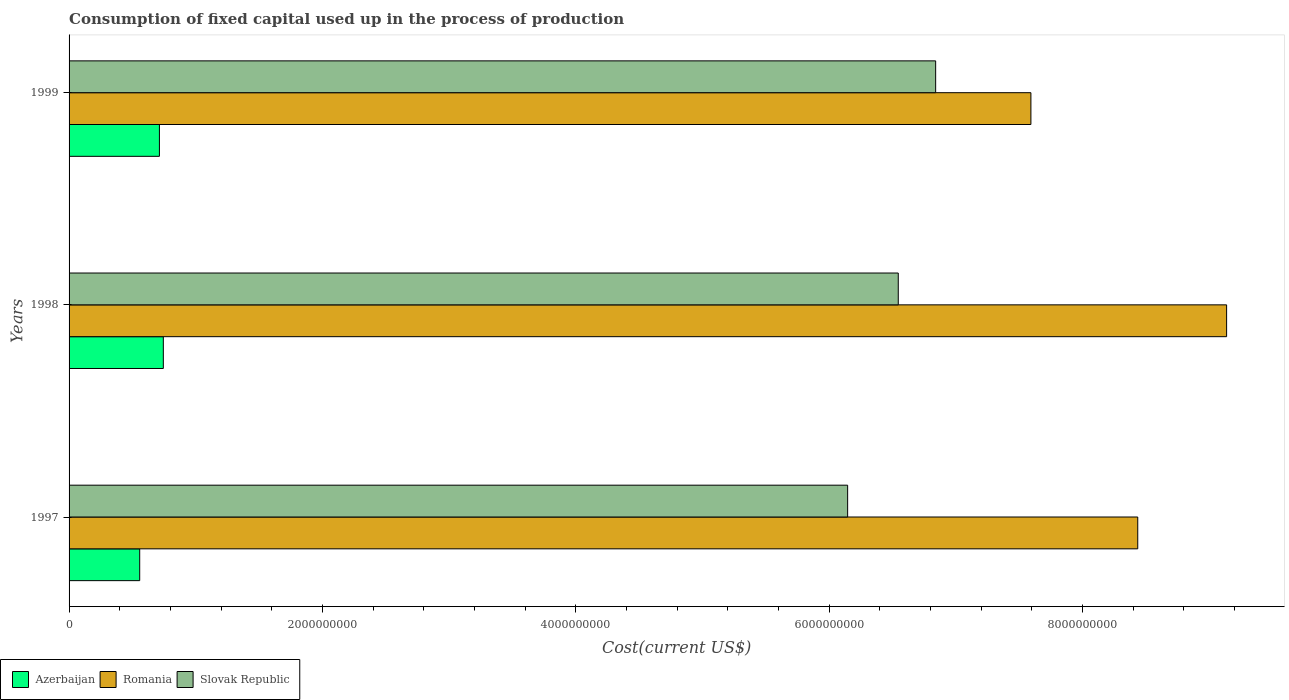Are the number of bars on each tick of the Y-axis equal?
Make the answer very short. Yes. How many bars are there on the 1st tick from the bottom?
Ensure brevity in your answer.  3. What is the amount consumed in the process of production in Slovak Republic in 1998?
Keep it short and to the point. 6.55e+09. Across all years, what is the maximum amount consumed in the process of production in Azerbaijan?
Your answer should be compact. 7.44e+08. Across all years, what is the minimum amount consumed in the process of production in Azerbaijan?
Give a very brief answer. 5.58e+08. In which year was the amount consumed in the process of production in Azerbaijan minimum?
Provide a succinct answer. 1997. What is the total amount consumed in the process of production in Romania in the graph?
Make the answer very short. 2.52e+1. What is the difference between the amount consumed in the process of production in Azerbaijan in 1998 and that in 1999?
Keep it short and to the point. 3.07e+07. What is the difference between the amount consumed in the process of production in Azerbaijan in 1998 and the amount consumed in the process of production in Romania in 1999?
Provide a short and direct response. -6.85e+09. What is the average amount consumed in the process of production in Azerbaijan per year?
Your response must be concise. 6.72e+08. In the year 1998, what is the difference between the amount consumed in the process of production in Azerbaijan and amount consumed in the process of production in Slovak Republic?
Your response must be concise. -5.80e+09. In how many years, is the amount consumed in the process of production in Slovak Republic greater than 8000000000 US$?
Your response must be concise. 0. What is the ratio of the amount consumed in the process of production in Slovak Republic in 1998 to that in 1999?
Make the answer very short. 0.96. Is the difference between the amount consumed in the process of production in Azerbaijan in 1997 and 1999 greater than the difference between the amount consumed in the process of production in Slovak Republic in 1997 and 1999?
Give a very brief answer. Yes. What is the difference between the highest and the second highest amount consumed in the process of production in Azerbaijan?
Ensure brevity in your answer.  3.07e+07. What is the difference between the highest and the lowest amount consumed in the process of production in Romania?
Ensure brevity in your answer.  1.55e+09. In how many years, is the amount consumed in the process of production in Romania greater than the average amount consumed in the process of production in Romania taken over all years?
Your response must be concise. 2. Is the sum of the amount consumed in the process of production in Romania in 1997 and 1998 greater than the maximum amount consumed in the process of production in Slovak Republic across all years?
Your response must be concise. Yes. What does the 3rd bar from the top in 1999 represents?
Give a very brief answer. Azerbaijan. What does the 3rd bar from the bottom in 1999 represents?
Make the answer very short. Slovak Republic. Is it the case that in every year, the sum of the amount consumed in the process of production in Romania and amount consumed in the process of production in Azerbaijan is greater than the amount consumed in the process of production in Slovak Republic?
Provide a short and direct response. Yes. How many bars are there?
Make the answer very short. 9. Are all the bars in the graph horizontal?
Provide a succinct answer. Yes. How many years are there in the graph?
Your answer should be compact. 3. What is the difference between two consecutive major ticks on the X-axis?
Your response must be concise. 2.00e+09. Does the graph contain grids?
Ensure brevity in your answer.  No. How are the legend labels stacked?
Offer a terse response. Horizontal. What is the title of the graph?
Provide a succinct answer. Consumption of fixed capital used up in the process of production. What is the label or title of the X-axis?
Offer a terse response. Cost(current US$). What is the label or title of the Y-axis?
Keep it short and to the point. Years. What is the Cost(current US$) in Azerbaijan in 1997?
Provide a succinct answer. 5.58e+08. What is the Cost(current US$) in Romania in 1997?
Offer a terse response. 8.44e+09. What is the Cost(current US$) of Slovak Republic in 1997?
Make the answer very short. 6.15e+09. What is the Cost(current US$) of Azerbaijan in 1998?
Keep it short and to the point. 7.44e+08. What is the Cost(current US$) of Romania in 1998?
Provide a succinct answer. 9.14e+09. What is the Cost(current US$) in Slovak Republic in 1998?
Your response must be concise. 6.55e+09. What is the Cost(current US$) of Azerbaijan in 1999?
Your response must be concise. 7.13e+08. What is the Cost(current US$) of Romania in 1999?
Your answer should be compact. 7.59e+09. What is the Cost(current US$) in Slovak Republic in 1999?
Your response must be concise. 6.84e+09. Across all years, what is the maximum Cost(current US$) in Azerbaijan?
Your answer should be very brief. 7.44e+08. Across all years, what is the maximum Cost(current US$) in Romania?
Make the answer very short. 9.14e+09. Across all years, what is the maximum Cost(current US$) of Slovak Republic?
Keep it short and to the point. 6.84e+09. Across all years, what is the minimum Cost(current US$) of Azerbaijan?
Give a very brief answer. 5.58e+08. Across all years, what is the minimum Cost(current US$) in Romania?
Ensure brevity in your answer.  7.59e+09. Across all years, what is the minimum Cost(current US$) in Slovak Republic?
Provide a short and direct response. 6.15e+09. What is the total Cost(current US$) of Azerbaijan in the graph?
Give a very brief answer. 2.02e+09. What is the total Cost(current US$) of Romania in the graph?
Your answer should be very brief. 2.52e+1. What is the total Cost(current US$) of Slovak Republic in the graph?
Give a very brief answer. 1.95e+1. What is the difference between the Cost(current US$) of Azerbaijan in 1997 and that in 1998?
Provide a short and direct response. -1.86e+08. What is the difference between the Cost(current US$) in Romania in 1997 and that in 1998?
Ensure brevity in your answer.  -7.02e+08. What is the difference between the Cost(current US$) in Slovak Republic in 1997 and that in 1998?
Give a very brief answer. -4.00e+08. What is the difference between the Cost(current US$) in Azerbaijan in 1997 and that in 1999?
Your response must be concise. -1.56e+08. What is the difference between the Cost(current US$) of Romania in 1997 and that in 1999?
Offer a terse response. 8.44e+08. What is the difference between the Cost(current US$) in Slovak Republic in 1997 and that in 1999?
Your answer should be compact. -6.95e+08. What is the difference between the Cost(current US$) in Azerbaijan in 1998 and that in 1999?
Your answer should be very brief. 3.07e+07. What is the difference between the Cost(current US$) of Romania in 1998 and that in 1999?
Ensure brevity in your answer.  1.55e+09. What is the difference between the Cost(current US$) in Slovak Republic in 1998 and that in 1999?
Make the answer very short. -2.95e+08. What is the difference between the Cost(current US$) in Azerbaijan in 1997 and the Cost(current US$) in Romania in 1998?
Offer a very short reply. -8.58e+09. What is the difference between the Cost(current US$) of Azerbaijan in 1997 and the Cost(current US$) of Slovak Republic in 1998?
Your response must be concise. -5.99e+09. What is the difference between the Cost(current US$) of Romania in 1997 and the Cost(current US$) of Slovak Republic in 1998?
Your response must be concise. 1.89e+09. What is the difference between the Cost(current US$) in Azerbaijan in 1997 and the Cost(current US$) in Romania in 1999?
Provide a succinct answer. -7.04e+09. What is the difference between the Cost(current US$) in Azerbaijan in 1997 and the Cost(current US$) in Slovak Republic in 1999?
Ensure brevity in your answer.  -6.28e+09. What is the difference between the Cost(current US$) in Romania in 1997 and the Cost(current US$) in Slovak Republic in 1999?
Your response must be concise. 1.60e+09. What is the difference between the Cost(current US$) of Azerbaijan in 1998 and the Cost(current US$) of Romania in 1999?
Offer a terse response. -6.85e+09. What is the difference between the Cost(current US$) of Azerbaijan in 1998 and the Cost(current US$) of Slovak Republic in 1999?
Offer a very short reply. -6.10e+09. What is the difference between the Cost(current US$) of Romania in 1998 and the Cost(current US$) of Slovak Republic in 1999?
Your answer should be compact. 2.30e+09. What is the average Cost(current US$) of Azerbaijan per year?
Keep it short and to the point. 6.72e+08. What is the average Cost(current US$) in Romania per year?
Make the answer very short. 8.39e+09. What is the average Cost(current US$) in Slovak Republic per year?
Your answer should be compact. 6.51e+09. In the year 1997, what is the difference between the Cost(current US$) in Azerbaijan and Cost(current US$) in Romania?
Make the answer very short. -7.88e+09. In the year 1997, what is the difference between the Cost(current US$) of Azerbaijan and Cost(current US$) of Slovak Republic?
Provide a short and direct response. -5.59e+09. In the year 1997, what is the difference between the Cost(current US$) of Romania and Cost(current US$) of Slovak Republic?
Offer a terse response. 2.29e+09. In the year 1998, what is the difference between the Cost(current US$) in Azerbaijan and Cost(current US$) in Romania?
Provide a short and direct response. -8.39e+09. In the year 1998, what is the difference between the Cost(current US$) of Azerbaijan and Cost(current US$) of Slovak Republic?
Keep it short and to the point. -5.80e+09. In the year 1998, what is the difference between the Cost(current US$) in Romania and Cost(current US$) in Slovak Republic?
Offer a very short reply. 2.59e+09. In the year 1999, what is the difference between the Cost(current US$) in Azerbaijan and Cost(current US$) in Romania?
Provide a short and direct response. -6.88e+09. In the year 1999, what is the difference between the Cost(current US$) of Azerbaijan and Cost(current US$) of Slovak Republic?
Your response must be concise. -6.13e+09. In the year 1999, what is the difference between the Cost(current US$) in Romania and Cost(current US$) in Slovak Republic?
Keep it short and to the point. 7.52e+08. What is the ratio of the Cost(current US$) of Azerbaijan in 1997 to that in 1998?
Give a very brief answer. 0.75. What is the ratio of the Cost(current US$) of Romania in 1997 to that in 1998?
Make the answer very short. 0.92. What is the ratio of the Cost(current US$) in Slovak Republic in 1997 to that in 1998?
Your response must be concise. 0.94. What is the ratio of the Cost(current US$) of Azerbaijan in 1997 to that in 1999?
Offer a very short reply. 0.78. What is the ratio of the Cost(current US$) of Slovak Republic in 1997 to that in 1999?
Give a very brief answer. 0.9. What is the ratio of the Cost(current US$) of Azerbaijan in 1998 to that in 1999?
Offer a very short reply. 1.04. What is the ratio of the Cost(current US$) in Romania in 1998 to that in 1999?
Provide a succinct answer. 1.2. What is the ratio of the Cost(current US$) in Slovak Republic in 1998 to that in 1999?
Make the answer very short. 0.96. What is the difference between the highest and the second highest Cost(current US$) of Azerbaijan?
Your response must be concise. 3.07e+07. What is the difference between the highest and the second highest Cost(current US$) of Romania?
Offer a very short reply. 7.02e+08. What is the difference between the highest and the second highest Cost(current US$) of Slovak Republic?
Keep it short and to the point. 2.95e+08. What is the difference between the highest and the lowest Cost(current US$) in Azerbaijan?
Your answer should be very brief. 1.86e+08. What is the difference between the highest and the lowest Cost(current US$) of Romania?
Offer a terse response. 1.55e+09. What is the difference between the highest and the lowest Cost(current US$) in Slovak Republic?
Your answer should be very brief. 6.95e+08. 